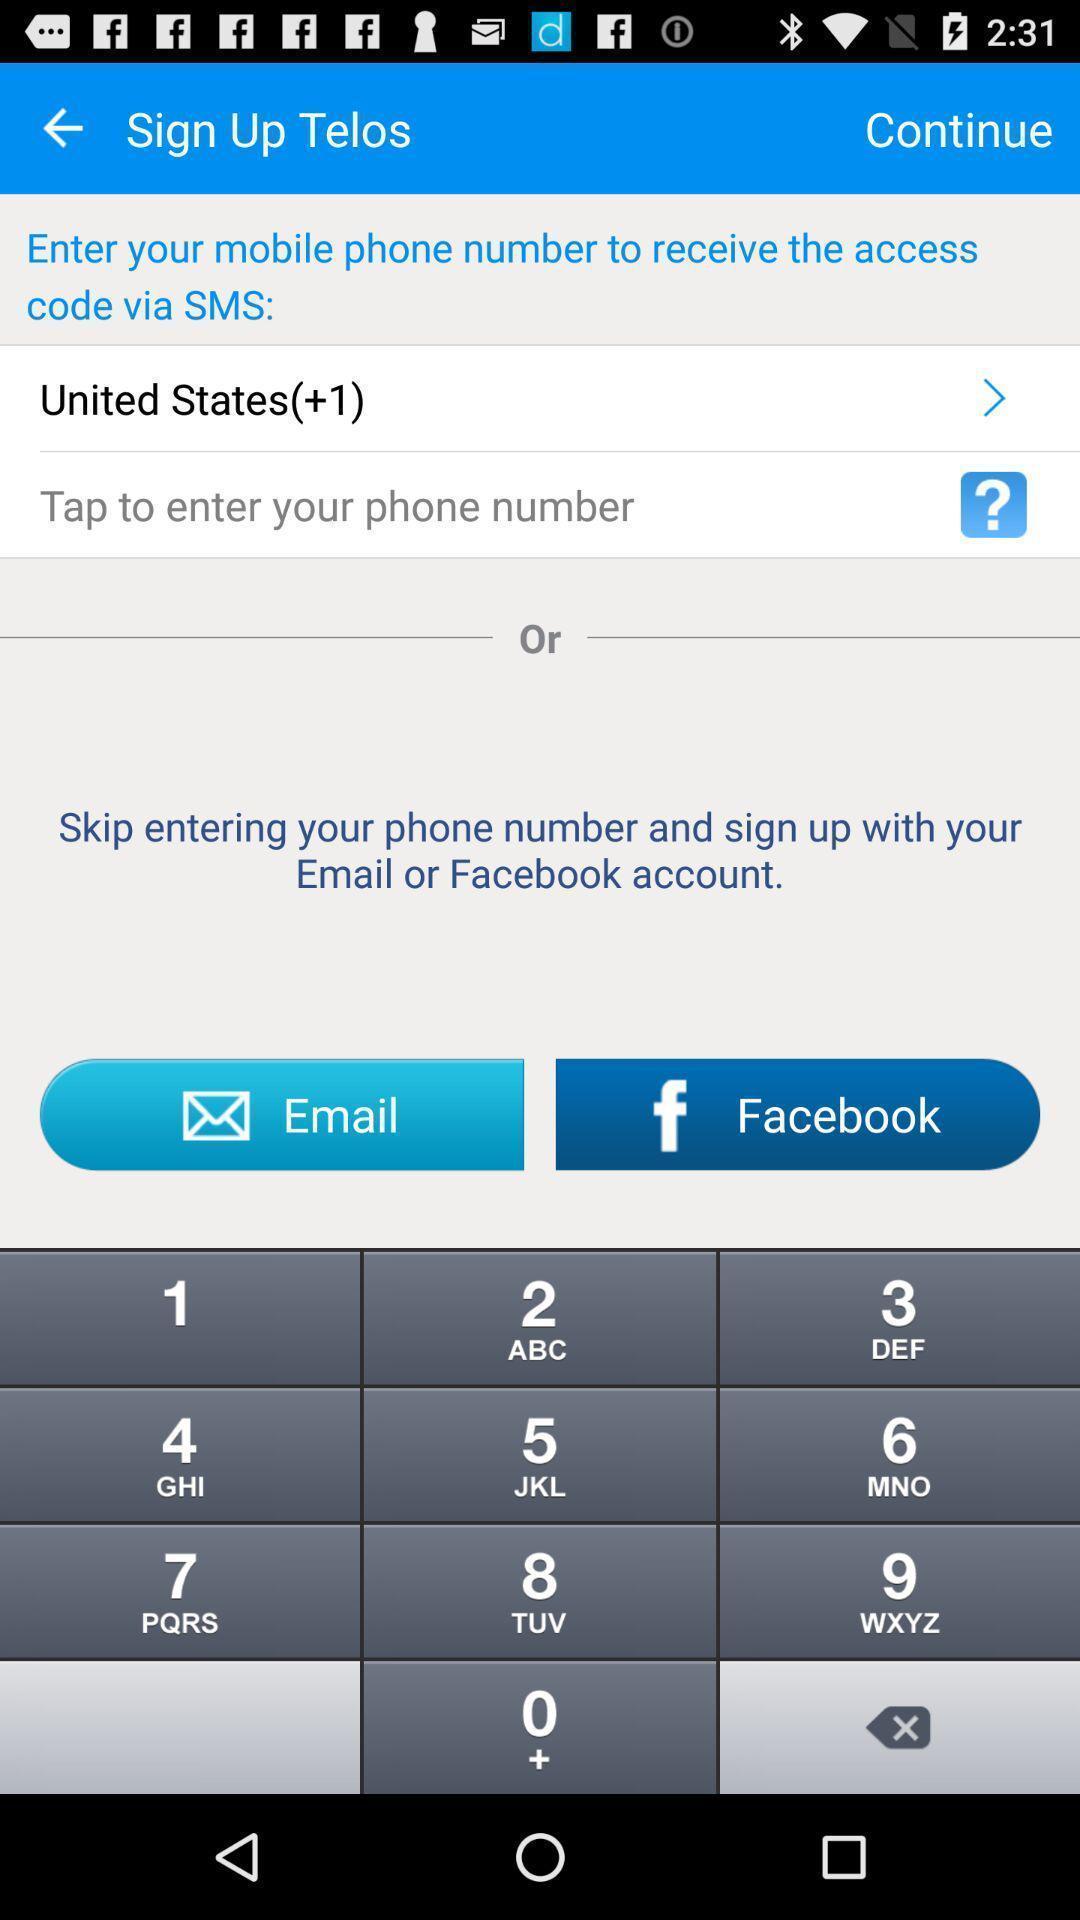Give me a summary of this screen capture. Sign up to access u.s calls and texts. 